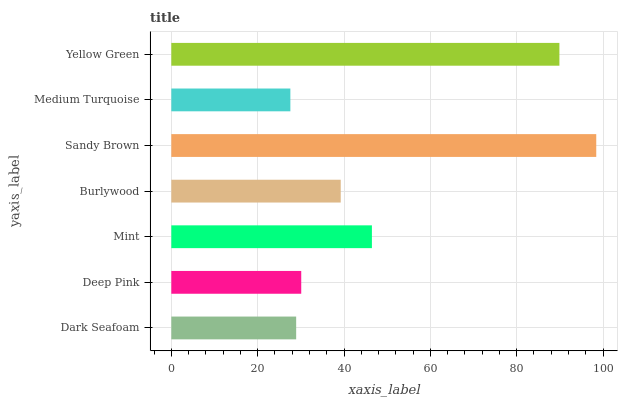Is Medium Turquoise the minimum?
Answer yes or no. Yes. Is Sandy Brown the maximum?
Answer yes or no. Yes. Is Deep Pink the minimum?
Answer yes or no. No. Is Deep Pink the maximum?
Answer yes or no. No. Is Deep Pink greater than Dark Seafoam?
Answer yes or no. Yes. Is Dark Seafoam less than Deep Pink?
Answer yes or no. Yes. Is Dark Seafoam greater than Deep Pink?
Answer yes or no. No. Is Deep Pink less than Dark Seafoam?
Answer yes or no. No. Is Burlywood the high median?
Answer yes or no. Yes. Is Burlywood the low median?
Answer yes or no. Yes. Is Mint the high median?
Answer yes or no. No. Is Sandy Brown the low median?
Answer yes or no. No. 